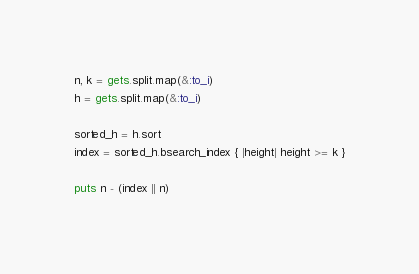<code> <loc_0><loc_0><loc_500><loc_500><_Ruby_>n, k = gets.split.map(&:to_i)
h = gets.split.map(&:to_i)

sorted_h = h.sort
index = sorted_h.bsearch_index { |height| height >= k }

puts n - (index || n)
</code> 